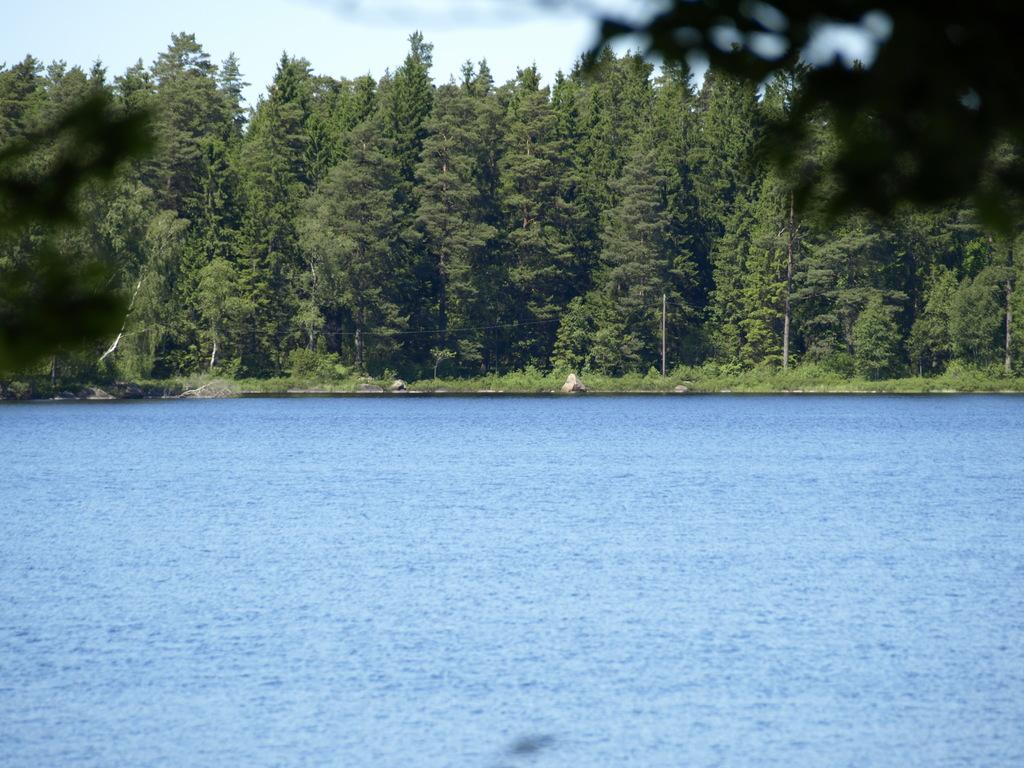What is at the bottom of the image? There is water at the bottom of the image. Can you describe the water in the image? The water might be in a river or a lake. What can be seen in the background of the image? There are trees in the background of the image. What is visible at the top of the image? The sky is visible at the top of the image. What type of paper is being used by the authority in the image? There is no authority or paper present in the image; it only features water, trees, and the sky. 